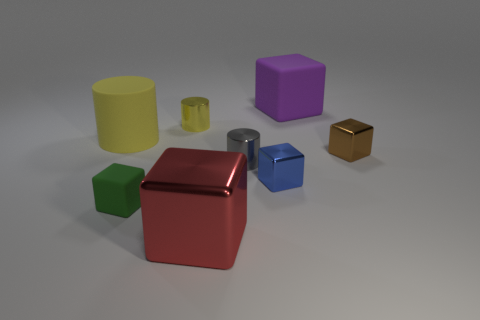Subtract all red cubes. How many cubes are left? 4 Subtract all big matte cubes. How many cubes are left? 4 Subtract 1 cubes. How many cubes are left? 4 Subtract all blue cubes. Subtract all red cylinders. How many cubes are left? 4 Add 1 blue rubber blocks. How many objects exist? 9 Subtract all cubes. How many objects are left? 3 Subtract all big rubber balls. Subtract all matte cubes. How many objects are left? 6 Add 8 green blocks. How many green blocks are left? 9 Add 4 shiny cubes. How many shiny cubes exist? 7 Subtract 0 green cylinders. How many objects are left? 8 